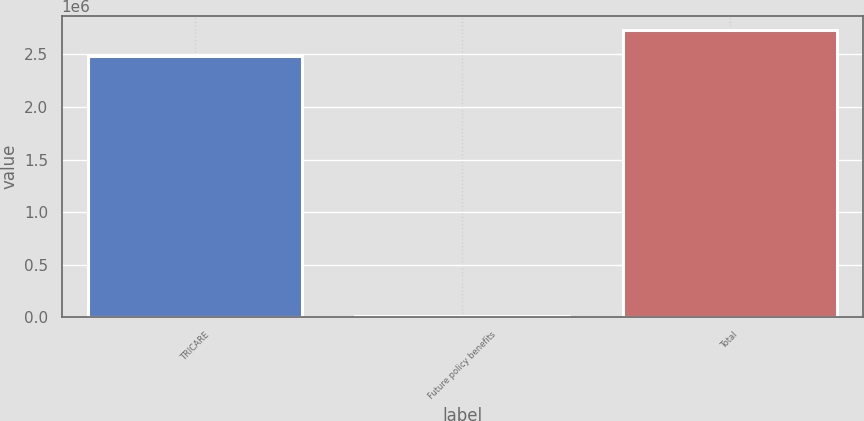Convert chart. <chart><loc_0><loc_0><loc_500><loc_500><bar_chart><fcel>TRICARE<fcel>Future policy benefits<fcel>Total<nl><fcel>2.48181e+06<fcel>16392<fcel>2.73e+06<nl></chart> 